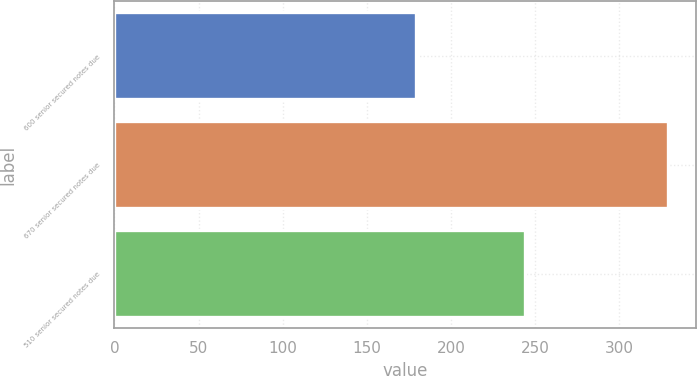<chart> <loc_0><loc_0><loc_500><loc_500><bar_chart><fcel>600 senior secured notes due<fcel>670 senior secured notes due<fcel>510 senior secured notes due<nl><fcel>179<fcel>329<fcel>244<nl></chart> 